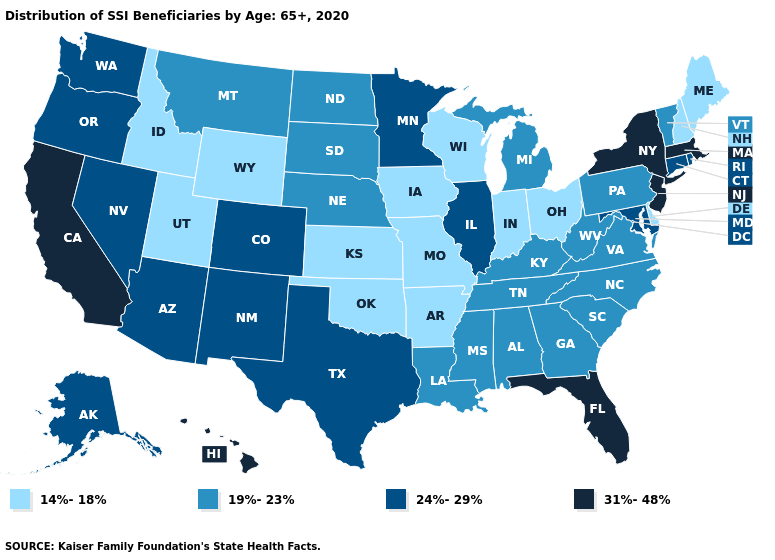Which states have the lowest value in the USA?
Be succinct. Arkansas, Delaware, Idaho, Indiana, Iowa, Kansas, Maine, Missouri, New Hampshire, Ohio, Oklahoma, Utah, Wisconsin, Wyoming. Name the states that have a value in the range 19%-23%?
Concise answer only. Alabama, Georgia, Kentucky, Louisiana, Michigan, Mississippi, Montana, Nebraska, North Carolina, North Dakota, Pennsylvania, South Carolina, South Dakota, Tennessee, Vermont, Virginia, West Virginia. Name the states that have a value in the range 14%-18%?
Write a very short answer. Arkansas, Delaware, Idaho, Indiana, Iowa, Kansas, Maine, Missouri, New Hampshire, Ohio, Oklahoma, Utah, Wisconsin, Wyoming. Does Rhode Island have the highest value in the USA?
Keep it brief. No. Does Florida have the highest value in the USA?
Concise answer only. Yes. What is the value of Texas?
Short answer required. 24%-29%. What is the value of Ohio?
Keep it brief. 14%-18%. Name the states that have a value in the range 31%-48%?
Short answer required. California, Florida, Hawaii, Massachusetts, New Jersey, New York. Among the states that border Delaware , which have the highest value?
Quick response, please. New Jersey. Does Pennsylvania have the lowest value in the USA?
Give a very brief answer. No. Name the states that have a value in the range 14%-18%?
Be succinct. Arkansas, Delaware, Idaho, Indiana, Iowa, Kansas, Maine, Missouri, New Hampshire, Ohio, Oklahoma, Utah, Wisconsin, Wyoming. Does California have the highest value in the USA?
Concise answer only. Yes. Is the legend a continuous bar?
Keep it brief. No. What is the highest value in the USA?
Quick response, please. 31%-48%. Which states have the lowest value in the Northeast?
Be succinct. Maine, New Hampshire. 